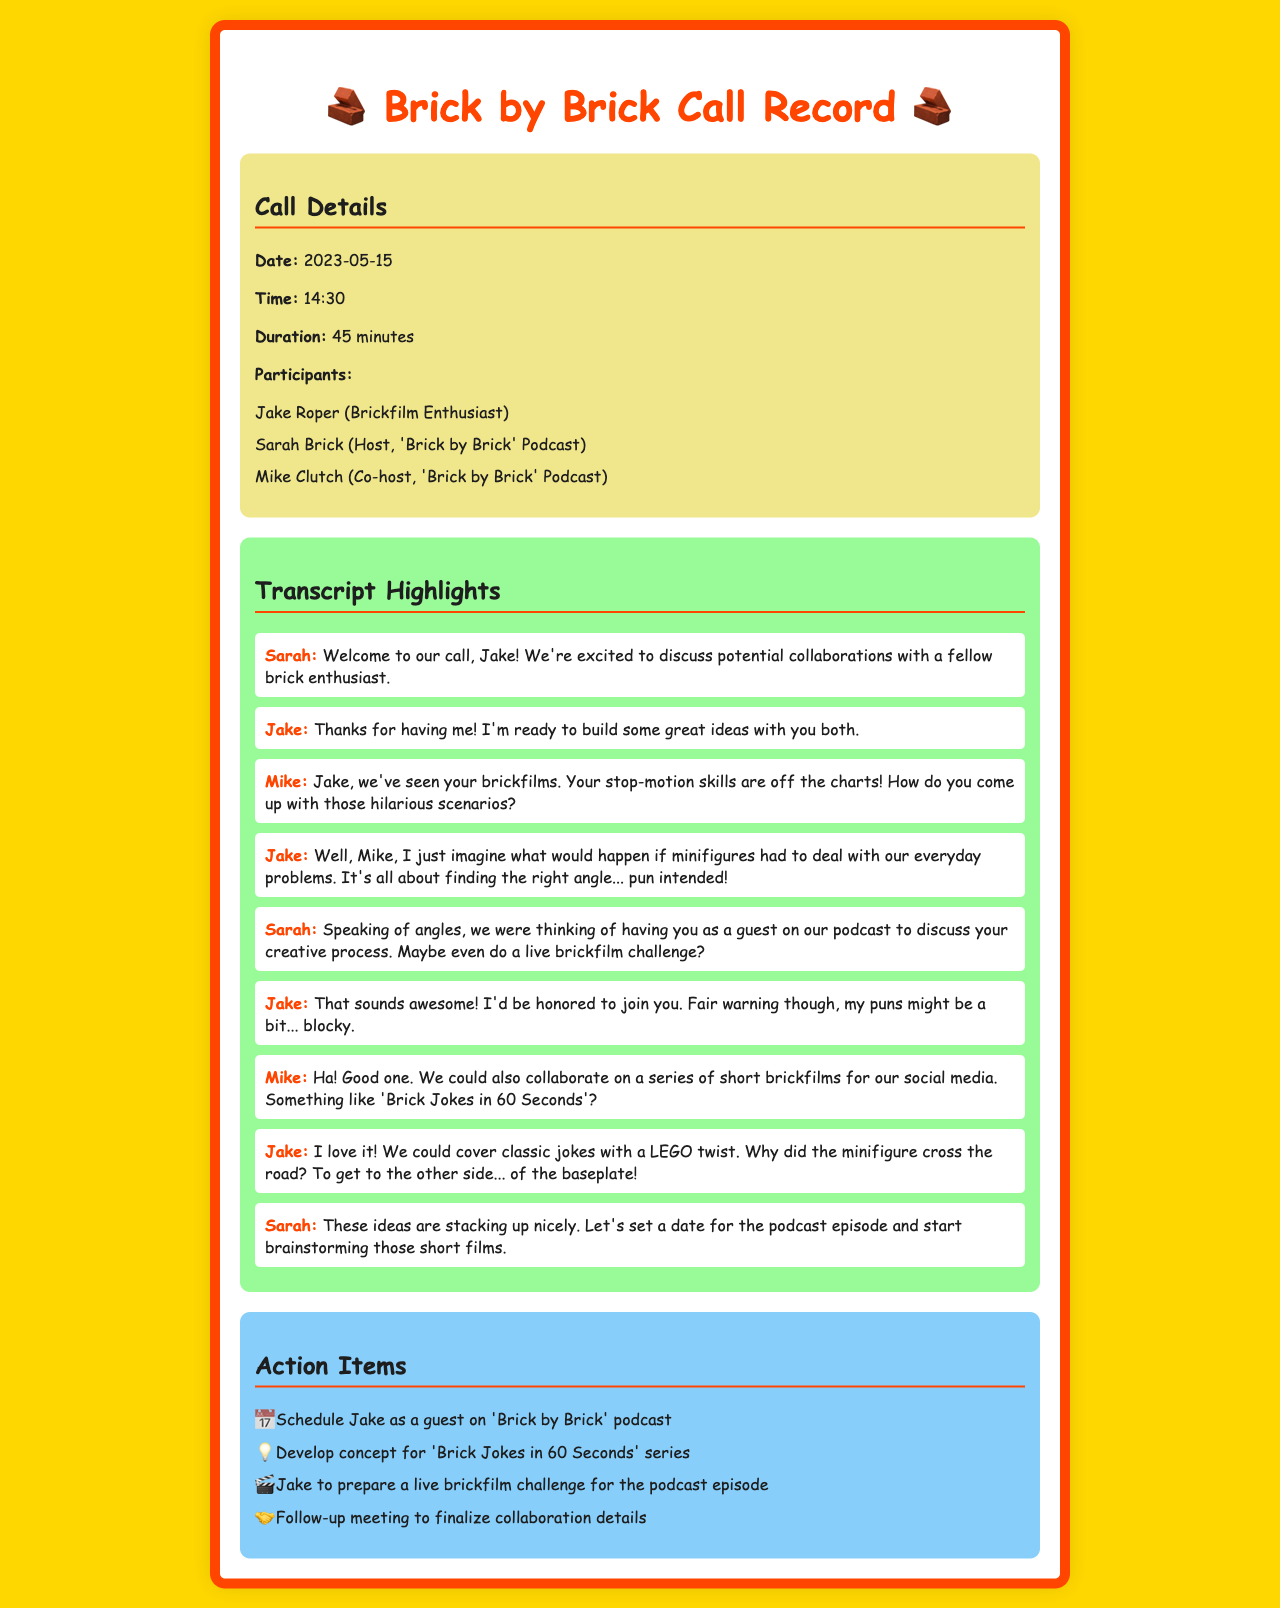What is the date of the call? The date of the call is specified in the "Call Details" section of the document.
Answer: 2023-05-15 Who is the host of the 'Brick by Brick' podcast? The host is listed in the "Call Details" of the document under participants.
Answer: Sarah Brick How long did the call last? The duration of the call is mentioned in the "Call Details" section.
Answer: 45 minutes What is one idea proposed for collaboration? The main collaboration ideas are discussed in the transcript highlights, specifically mentioning short films.
Answer: 'Brick Jokes in 60 Seconds' Who mentioned the puns during the call? The speaker who referenced the puns is indicated within the dialogue in the transcript section.
Answer: Jake What is the theme of the proposed podcast episode with Jake? The theme is related to discussing Jake's creative process during the podcast call.
Answer: Creative process Which participant suggested covering classic jokes with a LEGO twist? The participant proposing the idea of classic jokes with a LEGO twist is found in the dialogue section.
Answer: Jake What should Jake prepare for the podcast episode? The action items indicate what Jake needs to prepare before the episode.
Answer: A live brickfilm challenge How many action items are listed in the document? The number of action items can be determined by counting the list in the "Action Items" section.
Answer: Four 